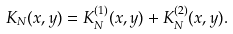<formula> <loc_0><loc_0><loc_500><loc_500>K _ { N } ( x , y ) = K _ { N } ^ { ( 1 ) } ( x , y ) + K _ { N } ^ { ( 2 ) } ( x , y ) .</formula> 